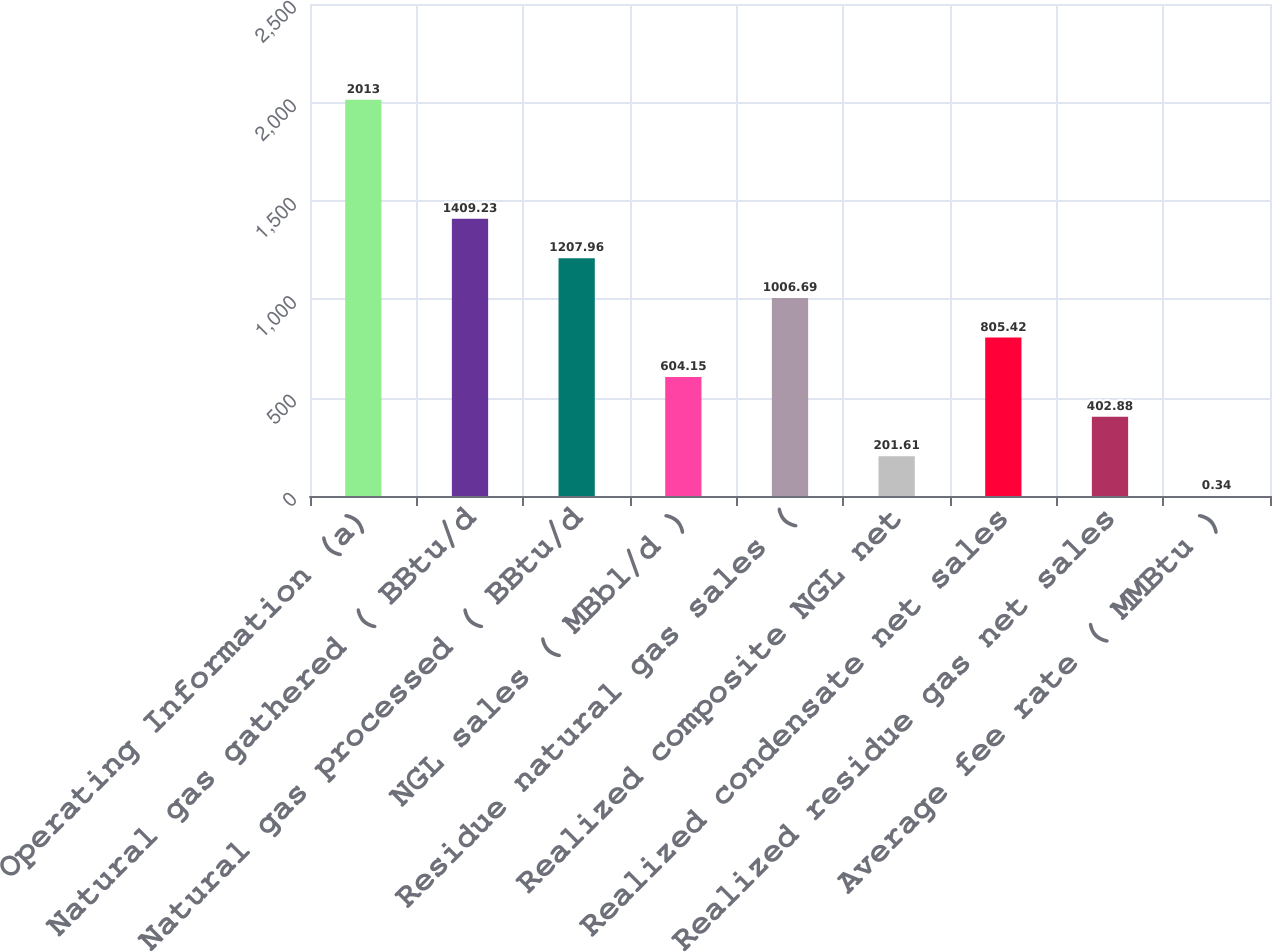Convert chart. <chart><loc_0><loc_0><loc_500><loc_500><bar_chart><fcel>Operating Information (a)<fcel>Natural gas gathered ( BBtu/d<fcel>Natural gas processed ( BBtu/d<fcel>NGL sales ( MBbl/d )<fcel>Residue natural gas sales (<fcel>Realized composite NGL net<fcel>Realized condensate net sales<fcel>Realized residue gas net sales<fcel>Average fee rate ( MMBtu )<nl><fcel>2013<fcel>1409.23<fcel>1207.96<fcel>604.15<fcel>1006.69<fcel>201.61<fcel>805.42<fcel>402.88<fcel>0.34<nl></chart> 